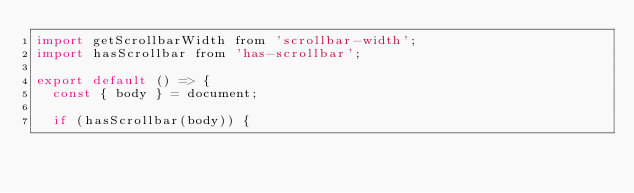Convert code to text. <code><loc_0><loc_0><loc_500><loc_500><_JavaScript_>import getScrollbarWidth from 'scrollbar-width';
import hasScrollbar from 'has-scrollbar';

export default () => {
  const { body } = document;

  if (hasScrollbar(body)) {</code> 